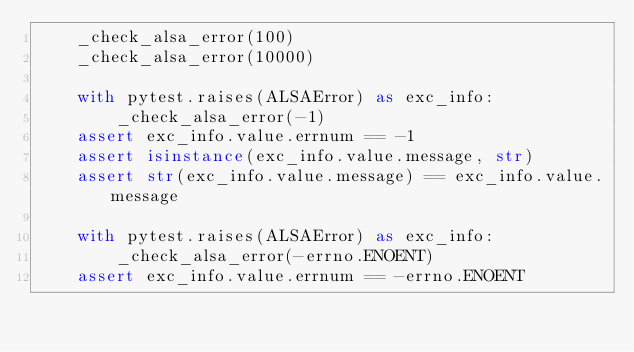Convert code to text. <code><loc_0><loc_0><loc_500><loc_500><_Python_>    _check_alsa_error(100)
    _check_alsa_error(10000)

    with pytest.raises(ALSAError) as exc_info:
        _check_alsa_error(-1)
    assert exc_info.value.errnum == -1
    assert isinstance(exc_info.value.message, str)
    assert str(exc_info.value.message) == exc_info.value.message

    with pytest.raises(ALSAError) as exc_info:
        _check_alsa_error(-errno.ENOENT)
    assert exc_info.value.errnum == -errno.ENOENT</code> 